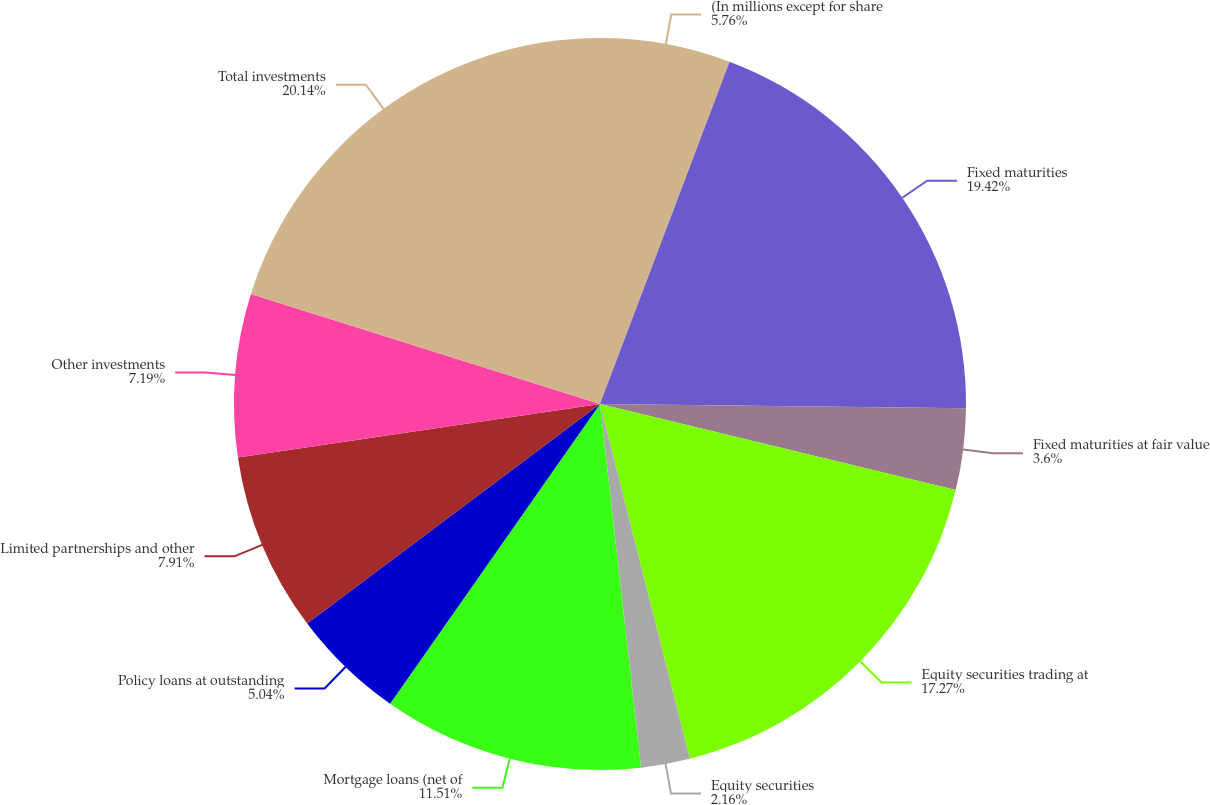<chart> <loc_0><loc_0><loc_500><loc_500><pie_chart><fcel>(In millions except for share<fcel>Fixed maturities<fcel>Fixed maturities at fair value<fcel>Equity securities trading at<fcel>Equity securities<fcel>Mortgage loans (net of<fcel>Policy loans at outstanding<fcel>Limited partnerships and other<fcel>Other investments<fcel>Total investments<nl><fcel>5.76%<fcel>19.42%<fcel>3.6%<fcel>17.27%<fcel>2.16%<fcel>11.51%<fcel>5.04%<fcel>7.91%<fcel>7.19%<fcel>20.14%<nl></chart> 